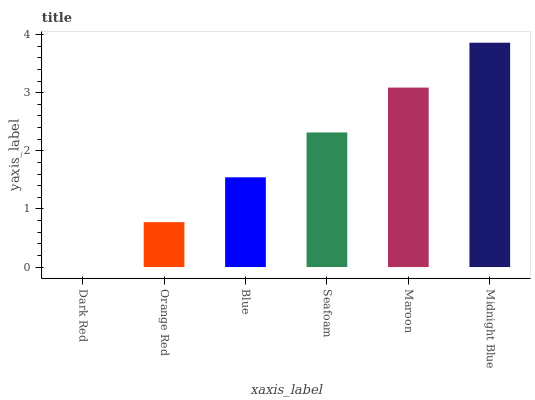Is Dark Red the minimum?
Answer yes or no. Yes. Is Midnight Blue the maximum?
Answer yes or no. Yes. Is Orange Red the minimum?
Answer yes or no. No. Is Orange Red the maximum?
Answer yes or no. No. Is Orange Red greater than Dark Red?
Answer yes or no. Yes. Is Dark Red less than Orange Red?
Answer yes or no. Yes. Is Dark Red greater than Orange Red?
Answer yes or no. No. Is Orange Red less than Dark Red?
Answer yes or no. No. Is Seafoam the high median?
Answer yes or no. Yes. Is Blue the low median?
Answer yes or no. Yes. Is Midnight Blue the high median?
Answer yes or no. No. Is Midnight Blue the low median?
Answer yes or no. No. 